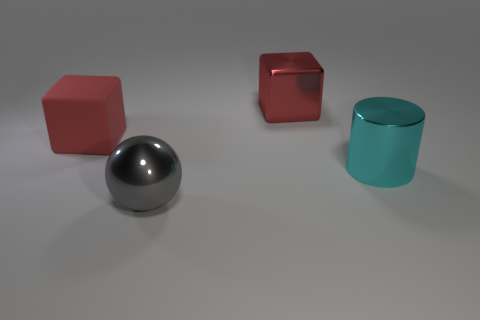Add 3 green rubber things. How many objects exist? 7 Subtract all spheres. How many objects are left? 3 Add 4 red rubber things. How many red rubber things exist? 5 Subtract 0 gray cylinders. How many objects are left? 4 Subtract all red shiny cubes. Subtract all big red rubber things. How many objects are left? 2 Add 4 metallic balls. How many metallic balls are left? 5 